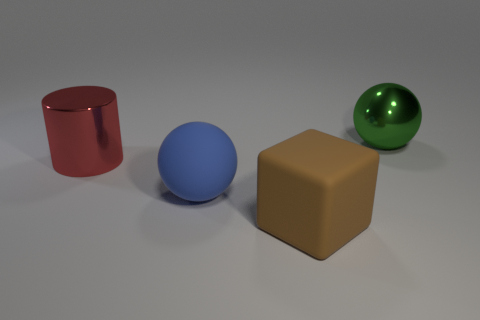Is the number of big things on the right side of the rubber cube the same as the number of big red metal blocks?
Give a very brief answer. No. What is the material of the large ball that is on the right side of the big sphere that is in front of the big metallic object in front of the big green metal sphere?
Give a very brief answer. Metal. There is a big metallic thing behind the big red shiny object; what color is it?
Ensure brevity in your answer.  Green. Is there any other thing that is the same shape as the green metal object?
Offer a very short reply. Yes. There is a metal object to the right of the matte object that is in front of the blue thing; how big is it?
Offer a very short reply. Large. Is the number of objects that are in front of the brown cube the same as the number of rubber blocks that are behind the large cylinder?
Make the answer very short. Yes. Is there any other thing that is the same size as the green shiny object?
Your response must be concise. Yes. There is a big sphere that is made of the same material as the red object; what color is it?
Give a very brief answer. Green. Are the big brown object and the big sphere left of the green metallic object made of the same material?
Ensure brevity in your answer.  Yes. What color is the large thing that is left of the block and behind the large blue object?
Offer a very short reply. Red. 